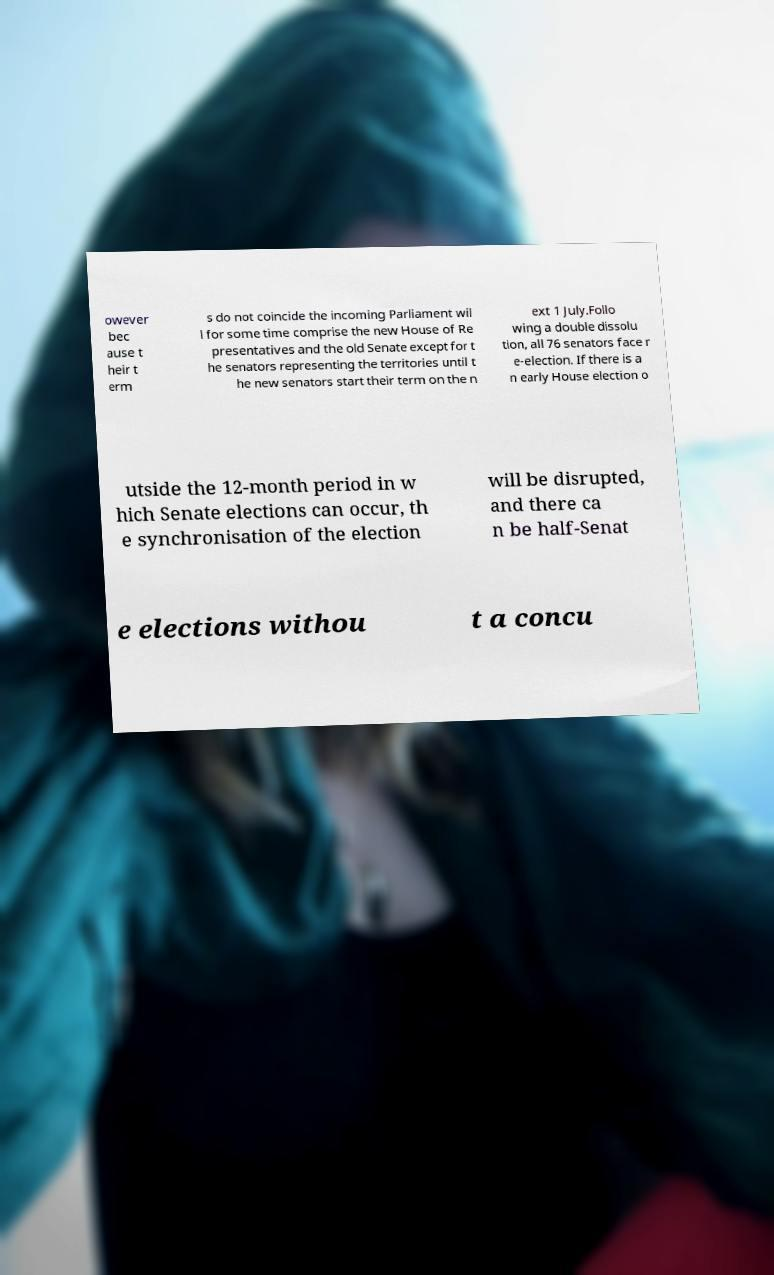There's text embedded in this image that I need extracted. Can you transcribe it verbatim? owever bec ause t heir t erm s do not coincide the incoming Parliament wil l for some time comprise the new House of Re presentatives and the old Senate except for t he senators representing the territories until t he new senators start their term on the n ext 1 July.Follo wing a double dissolu tion, all 76 senators face r e-election. If there is a n early House election o utside the 12-month period in w hich Senate elections can occur, th e synchronisation of the election will be disrupted, and there ca n be half-Senat e elections withou t a concu 